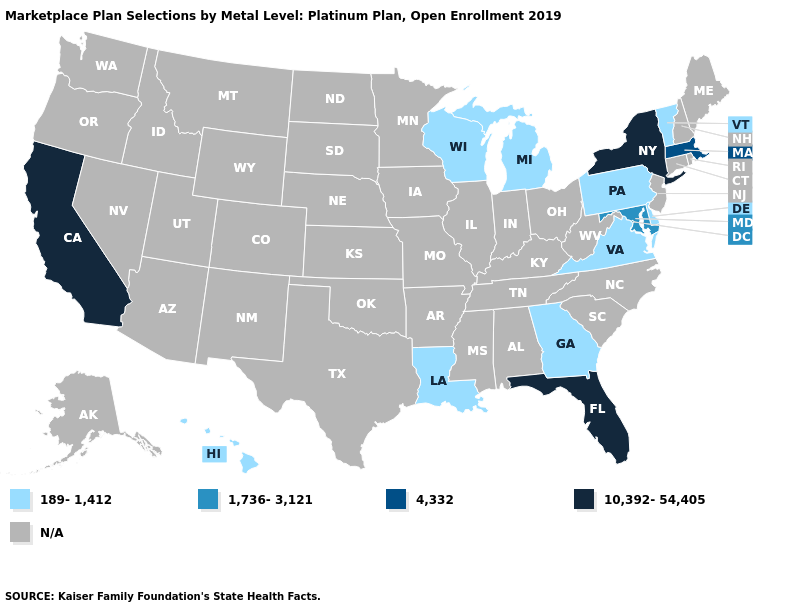Is the legend a continuous bar?
Keep it brief. No. What is the value of Kentucky?
Quick response, please. N/A. What is the highest value in the MidWest ?
Write a very short answer. 189-1,412. What is the value of Texas?
Write a very short answer. N/A. What is the highest value in the USA?
Give a very brief answer. 10,392-54,405. Name the states that have a value in the range 4,332?
Concise answer only. Massachusetts. What is the value of Kentucky?
Be succinct. N/A. Is the legend a continuous bar?
Be succinct. No. What is the value of Colorado?
Concise answer only. N/A. Does the map have missing data?
Concise answer only. Yes. What is the highest value in the USA?
Give a very brief answer. 10,392-54,405. Name the states that have a value in the range 1,736-3,121?
Write a very short answer. Maryland. Name the states that have a value in the range 189-1,412?
Quick response, please. Delaware, Georgia, Hawaii, Louisiana, Michigan, Pennsylvania, Vermont, Virginia, Wisconsin. 